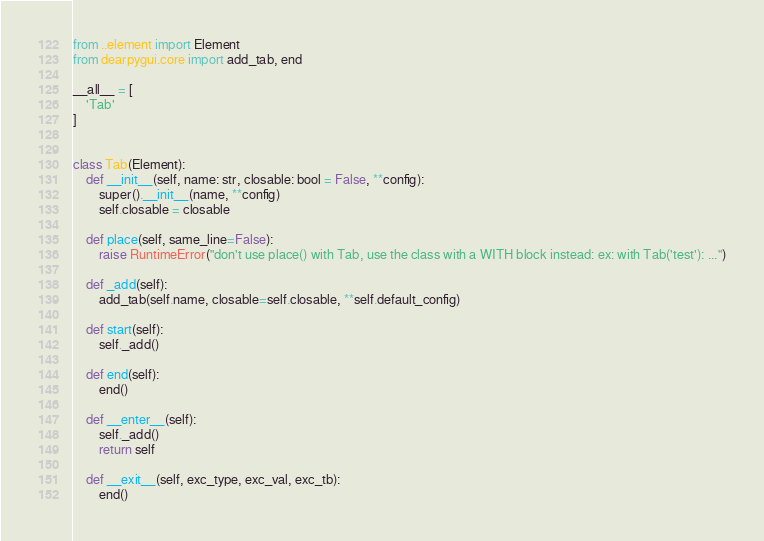Convert code to text. <code><loc_0><loc_0><loc_500><loc_500><_Python_>from ..element import Element
from dearpygui.core import add_tab, end

__all__ = [
    'Tab'
]


class Tab(Element):
    def __init__(self, name: str, closable: bool = False, **config):
        super().__init__(name, **config)
        self.closable = closable

    def place(self, same_line=False):
        raise RuntimeError("don't use place() with Tab, use the class with a WITH block instead: ex: with Tab('test'): ...")

    def _add(self):
        add_tab(self.name, closable=self.closable, **self.default_config)

    def start(self):
        self._add()

    def end(self):
        end()

    def __enter__(self):
        self._add()
        return self

    def __exit__(self, exc_type, exc_val, exc_tb):
        end()
</code> 